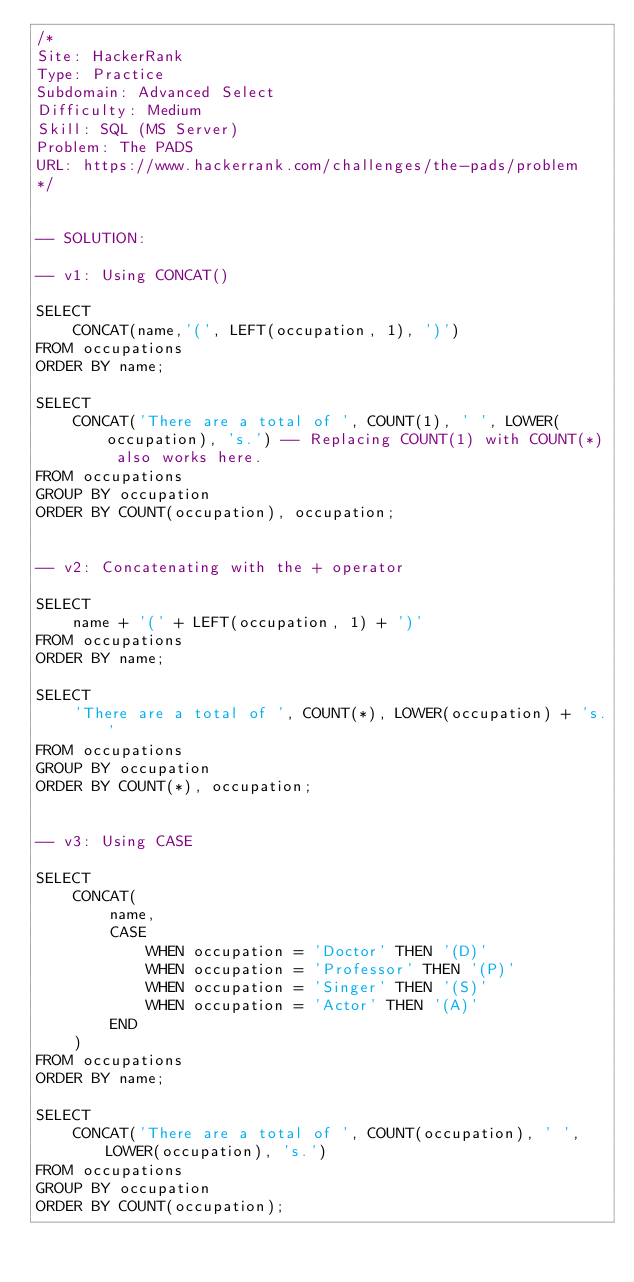Convert code to text. <code><loc_0><loc_0><loc_500><loc_500><_SQL_>/*
Site: HackerRank
Type: Practice
Subdomain: Advanced Select
Difficulty: Medium
Skill: SQL (MS Server)
Problem: The PADS
URL: https://www.hackerrank.com/challenges/the-pads/problem
*/


-- SOLUTION:

-- v1: Using CONCAT()

SELECT 
    CONCAT(name,'(', LEFT(occupation, 1), ')')
FROM occupations
ORDER BY name;
       
SELECT 
    CONCAT('There are a total of ', COUNT(1), ' ', LOWER(occupation), 's.') -- Replacing COUNT(1) with COUNT(*) also works here.
FROM occupations
GROUP BY occupation
ORDER BY COUNT(occupation), occupation;


-- v2: Concatenating with the + operator

SELECT 
    name + '(' + LEFT(occupation, 1) + ')'
FROM occupations
ORDER BY name;

SELECT 
    'There are a total of ', COUNT(*), LOWER(occupation) + 's.'
FROM occupations
GROUP BY occupation
ORDER BY COUNT(*), occupation;


-- v3: Using CASE

SELECT 
    CONCAT(
        name, 
        CASE 
            WHEN occupation = 'Doctor' THEN '(D)'
            WHEN occupation = 'Professor' THEN '(P)'
            WHEN occupation = 'Singer' THEN '(S)'
            WHEN occupation = 'Actor' THEN '(A)'
        END
    )
FROM occupations 
ORDER BY name;

SELECT 
    CONCAT('There are a total of ', COUNT(occupation), ' ', LOWER(occupation), 's.')  
FROM occupations 
GROUP BY occupation 
ORDER BY COUNT(occupation);
</code> 